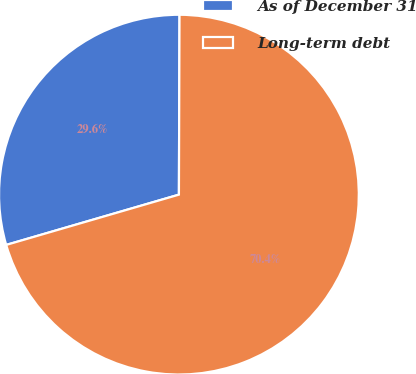Convert chart. <chart><loc_0><loc_0><loc_500><loc_500><pie_chart><fcel>As of December 31<fcel>Long-term debt<nl><fcel>29.56%<fcel>70.44%<nl></chart> 